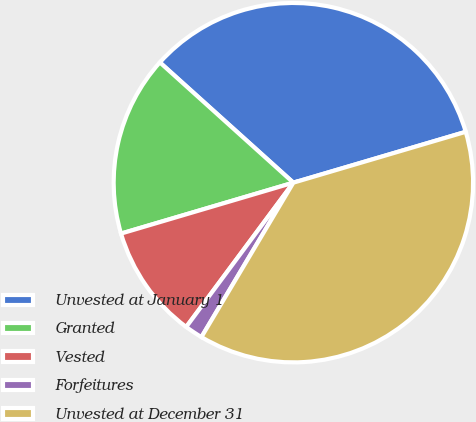Convert chart to OTSL. <chart><loc_0><loc_0><loc_500><loc_500><pie_chart><fcel>Unvested at January 1<fcel>Granted<fcel>Vested<fcel>Forfeitures<fcel>Unvested at December 31<nl><fcel>33.76%<fcel>16.24%<fcel>10.26%<fcel>1.62%<fcel>38.11%<nl></chart> 